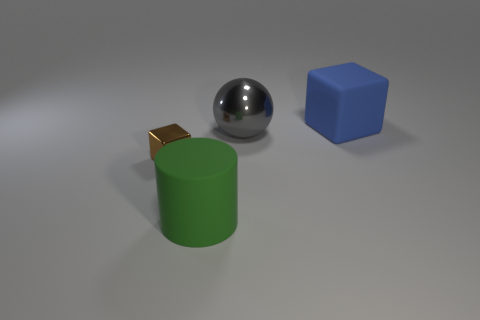Add 4 tiny brown shiny things. How many objects exist? 8 Subtract all cylinders. How many objects are left? 3 Add 3 blue things. How many blue things are left? 4 Add 3 tiny metallic objects. How many tiny metallic objects exist? 4 Subtract 1 blue cubes. How many objects are left? 3 Subtract all large purple rubber spheres. Subtract all green things. How many objects are left? 3 